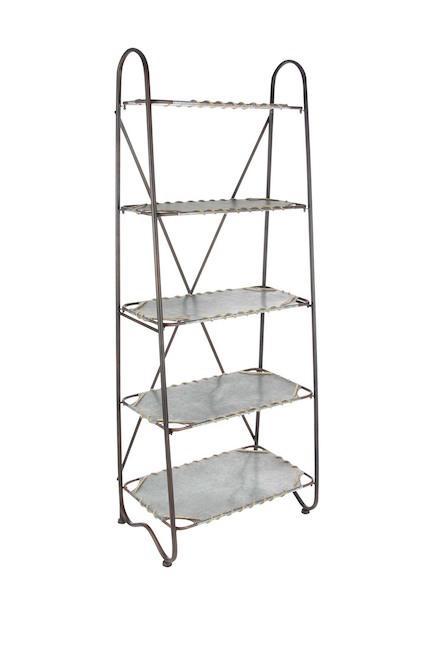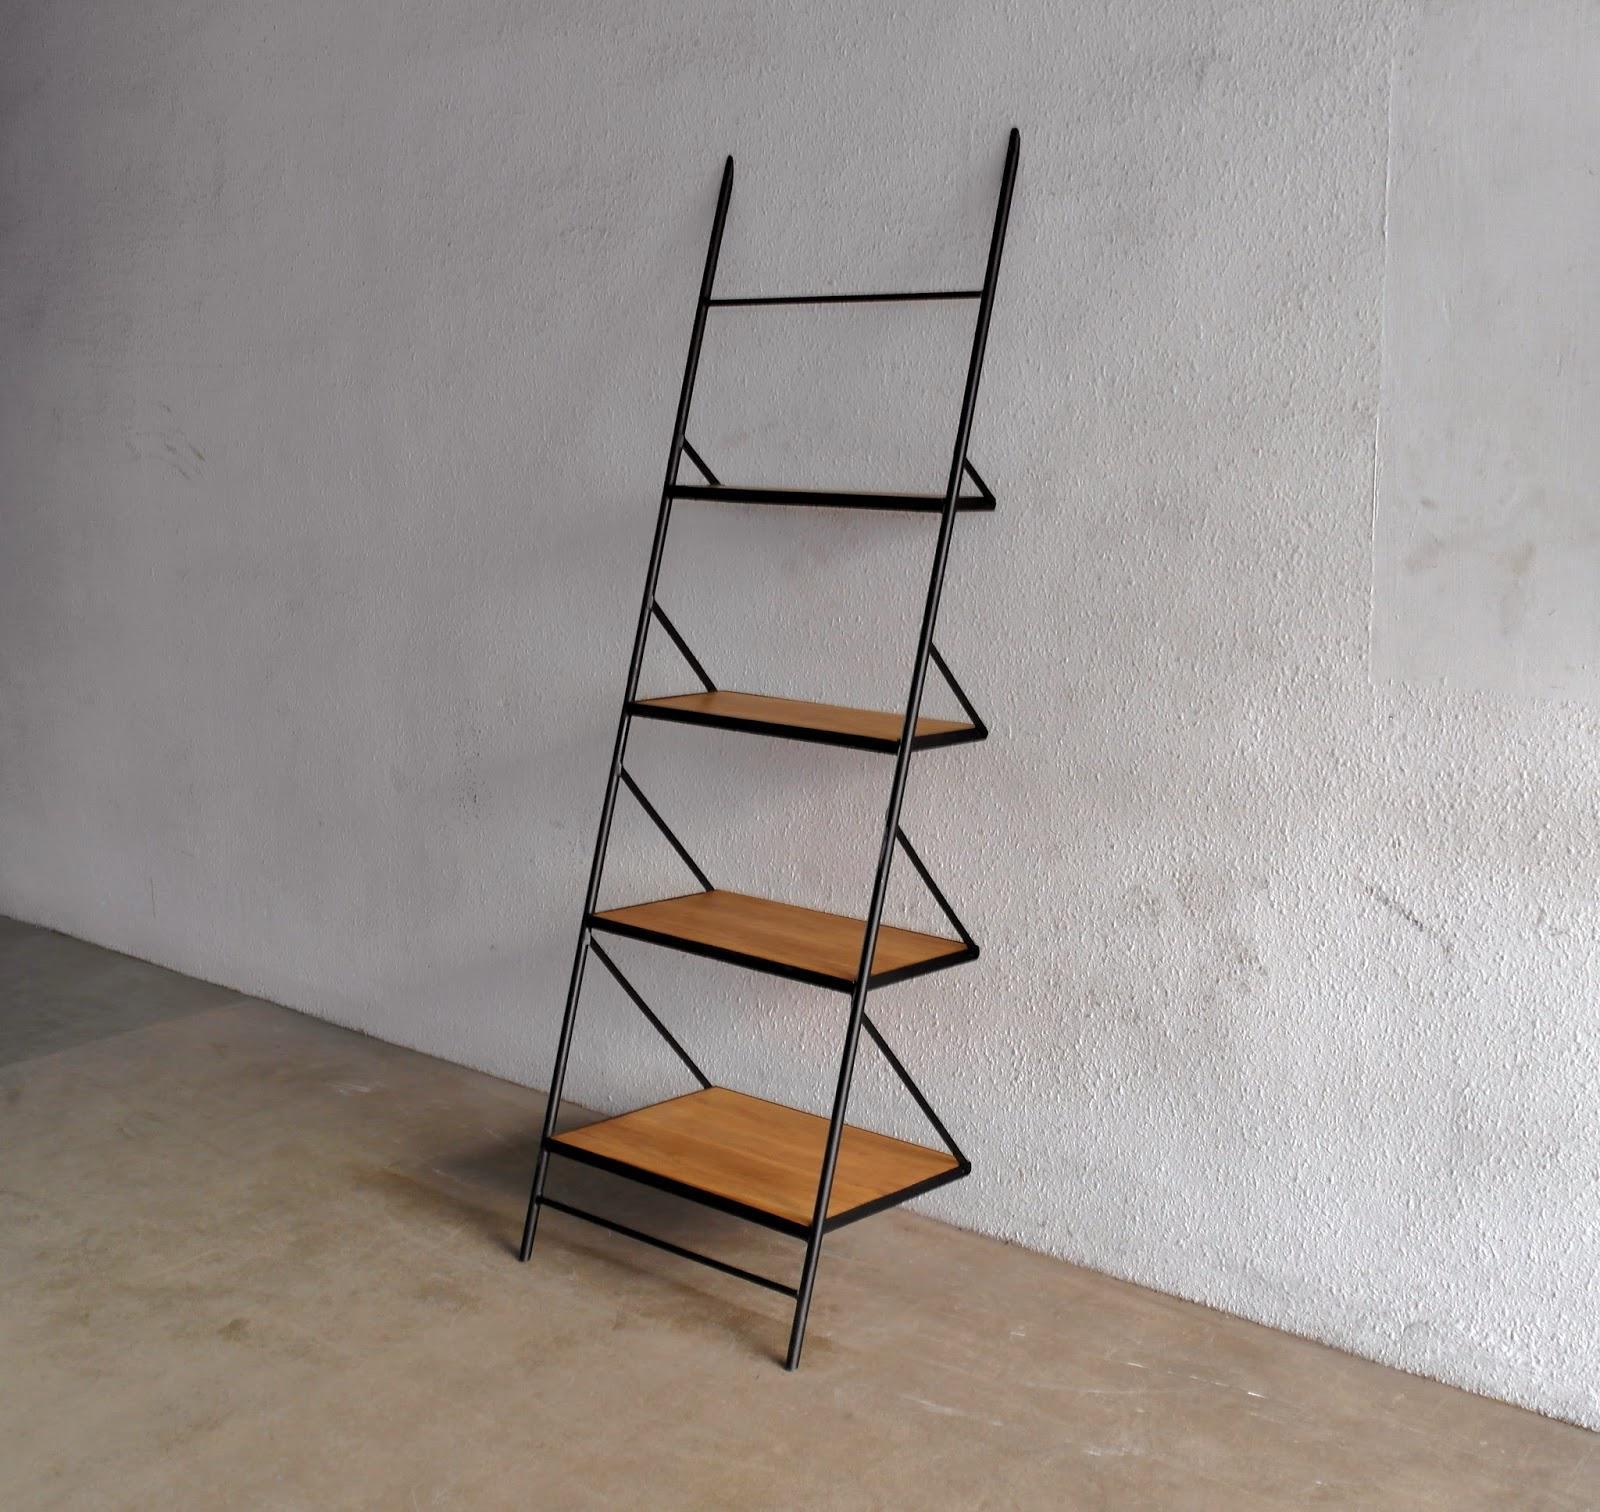The first image is the image on the left, the second image is the image on the right. For the images shown, is this caption "At least one shelf has items on it." true? Answer yes or no. No. 